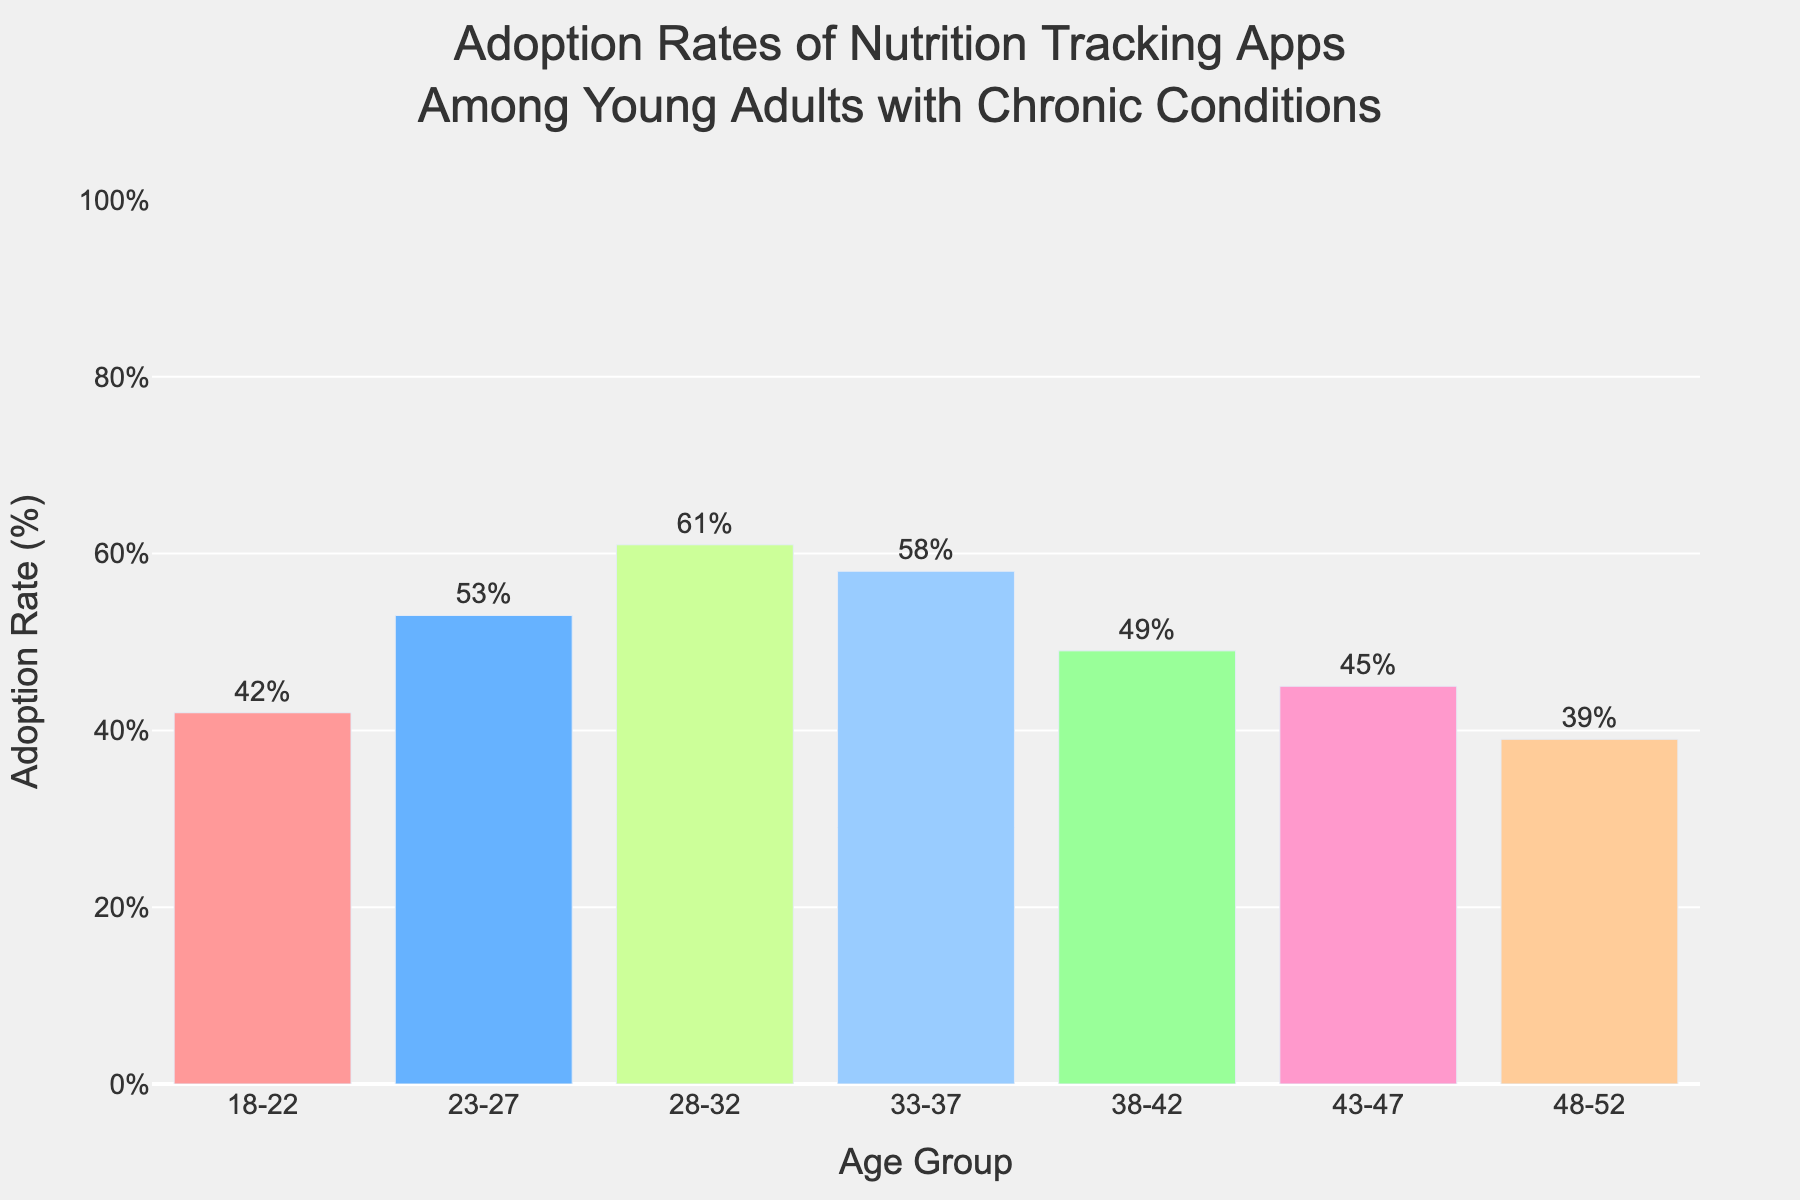What is the highest adoption rate recorded in the chart? The highest bar in the chart corresponds to the age group of 28-32, with an adoption rate of 61%.
Answer: 61% Which age group has the lowest adoption rate? The shortest bar represents the 48-52 age group, with an adoption rate of 39%.
Answer: 48-52 How much higher is the adoption rate in the 23-27 age group compared to the 43-47 age group? The adoption rate for the 23-27 age group is 53%, while for the 43-47 age group, it is 45%. The difference is 53% - 45% = 8%.
Answer: 8% What is the average adoption rate across all age groups? The adoption rates are 42, 53, 61, 58, 49, 45, and 39. Sum these rates to get 347, then divide by the number of age groups (7). The average is 347 / 7 ≈ 49.57%.
Answer: 49.57% Which two age groups have an adoption rate difference of 16%? Comparing the adoption rates, the difference of 16% occurs between the 28-32 age group (61%) and the 18-22 age group (42%).
Answer: 28-32 and 18-22 How does the adoption rate for the 33-37 age group visually compare to the 38-42 age group? The bar for the 33-37 group is slightly taller than the 38-42 group's bar; specifically, the adoption rate for the 33-37 is 58%, compared to the 49% for the 38-42 age group.
Answer: 33-37 is higher What is the median adoption rate across the age groups, and how did you find it? To find the median, list the adoption rates in ascending order: 39, 42, 45, 49, 53, 58, 61. The median is the middle value, which is 49%.
Answer: 49% What is the sum of the adoption rates for the youngest and the oldest age groups in this chart? The adoption rates for the 18-22 and 48-52 age groups are 42% and 39%. The sum is 42 + 39 = 81%.
Answer: 81% Which age groups have an adoption rate greater than 50%? The age groups 23-27, 28-32, and 33-37 have adoption rates higher than 50%, specifically 53%, 61%, and 58%.
Answer: 23-27, 28-32, 33-37 